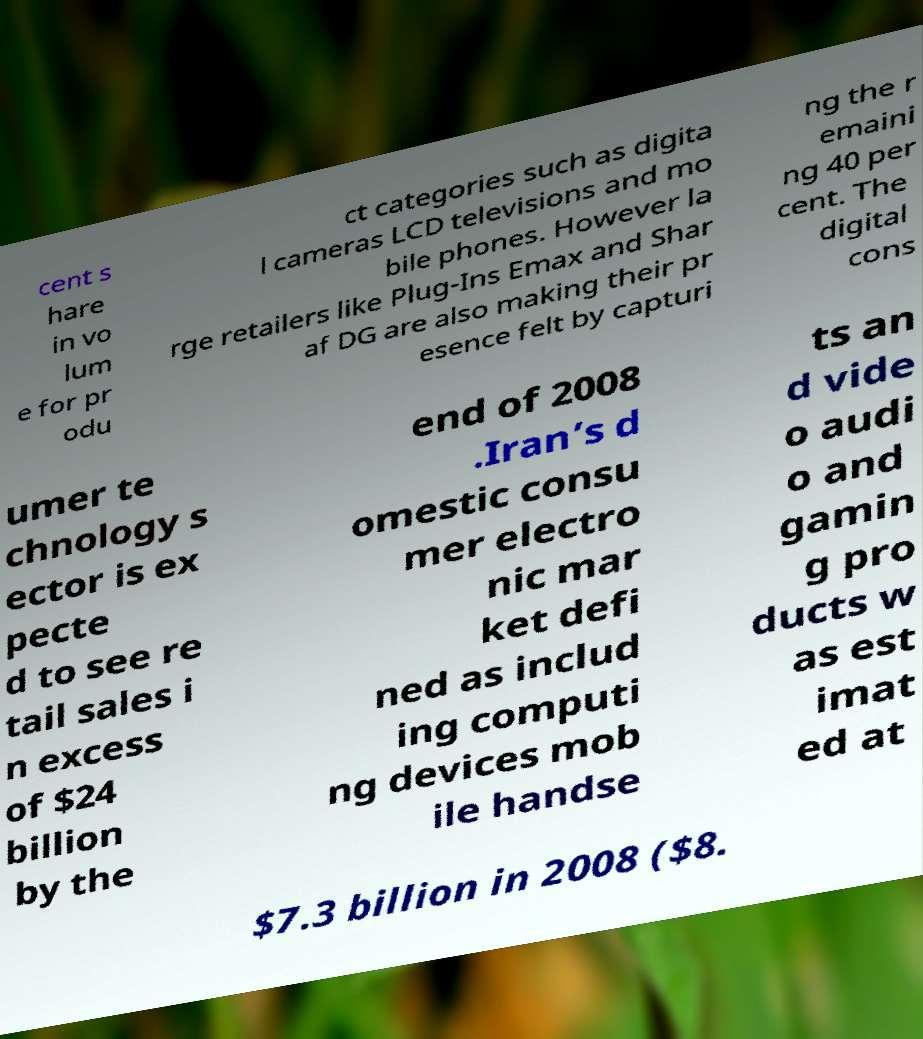Could you assist in decoding the text presented in this image and type it out clearly? cent s hare in vo lum e for pr odu ct categories such as digita l cameras LCD televisions and mo bile phones. However la rge retailers like Plug-Ins Emax and Shar af DG are also making their pr esence felt by capturi ng the r emaini ng 40 per cent. The digital cons umer te chnology s ector is ex pecte d to see re tail sales i n excess of $24 billion by the end of 2008 .Iran’s d omestic consu mer electro nic mar ket defi ned as includ ing computi ng devices mob ile handse ts an d vide o audi o and gamin g pro ducts w as est imat ed at $7.3 billion in 2008 ($8. 